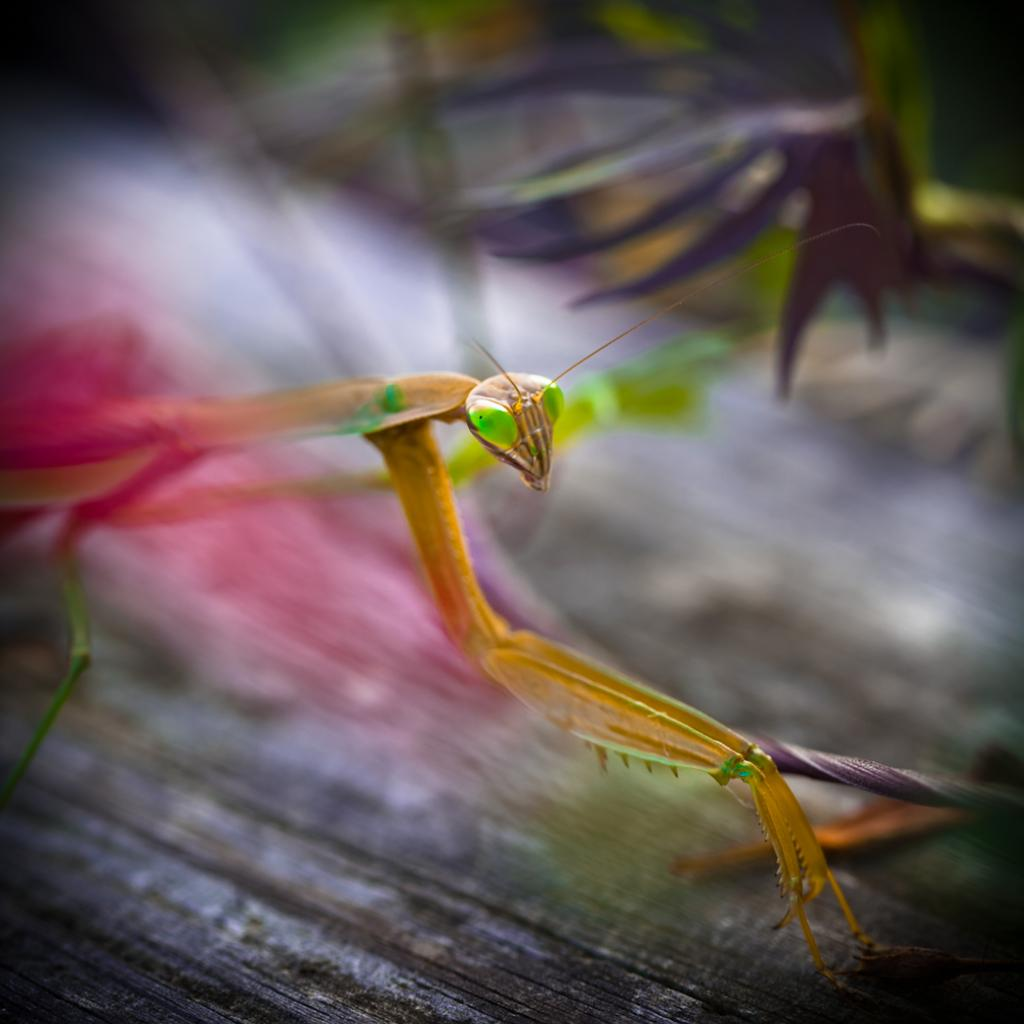What type of creature is present in the image? There is an insect in the image. Where is the insect located in the image? The insect is on an object. Can you describe the background of the image? The background of the image is blurred. How many pizzas are visible in the image? There are no pizzas present in the image. What type of bird can be seen in the image? There is no bird present in the image; it features an insect. 